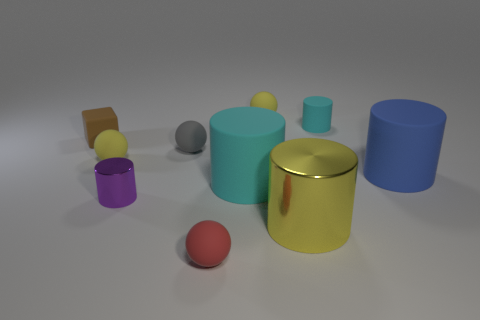What is the tiny yellow sphere that is to the left of the tiny yellow matte sphere behind the tiny yellow rubber thing to the left of the tiny red sphere made of? The tiny yellow sphere in question, positioned left of the matte-finished sphere and behind the yellow rubber object, also to the left of the tiny red sphere, appears to be made of a plastic or rubber-like material, based on its texture and light reflection properties. Its surface is smooth and has a shiny finish indicating it's likely a synthetic and flexible material, commonly used for creating small object replicas or toys. 